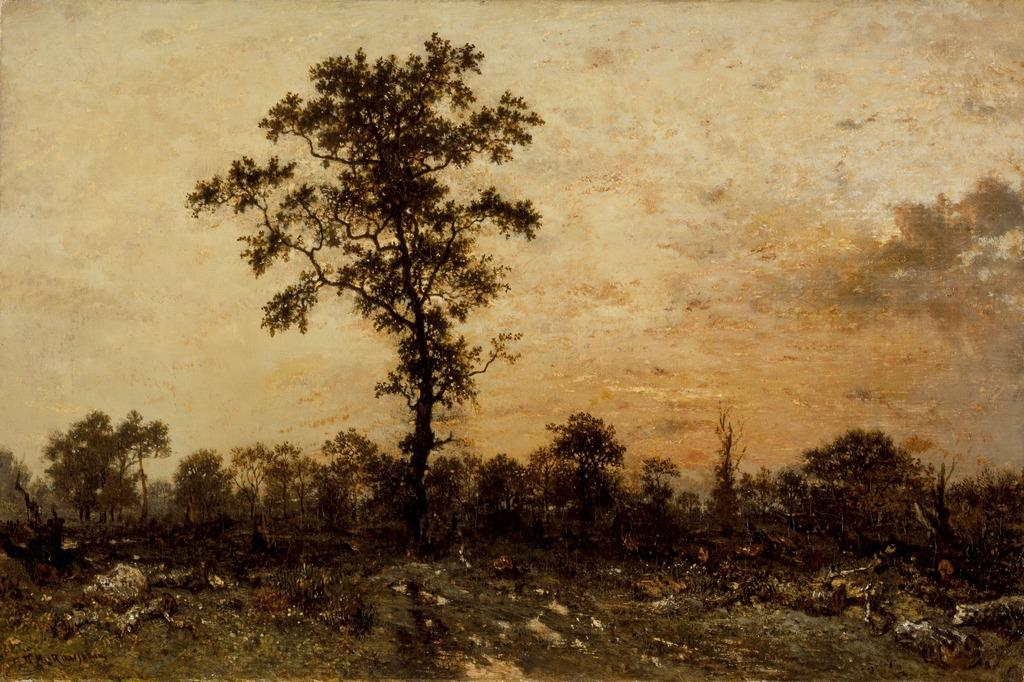What is the main subject in the center of the image? There is a tree in the center of the image. What can be seen in the background of the image? There are trees in the background of the image. What type of vegetation is at the bottom of the image? There is grass at the bottom of the image. What else is present at the bottom of the image? There are rocks at the bottom of the image. What is visible at the top of the image? The sky is visible at the top of the image. What type of wheel is visible in the image? There is no wheel present in the image. How does the friction between the tree and the rocks affect the growth of the grass? The image does not provide information about the friction between the tree and the rocks, nor does it show any grass growth. 